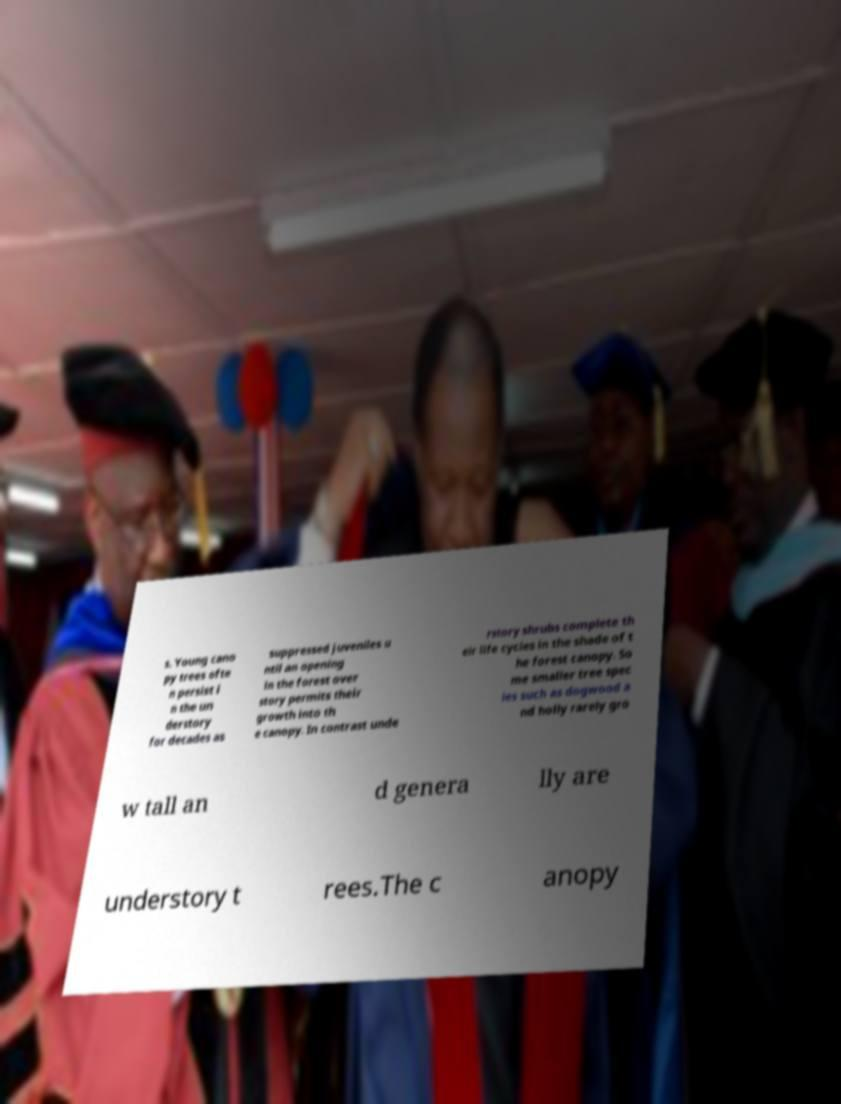Please identify and transcribe the text found in this image. s. Young cano py trees ofte n persist i n the un derstory for decades as suppressed juveniles u ntil an opening in the forest over story permits their growth into th e canopy. In contrast unde rstory shrubs complete th eir life cycles in the shade of t he forest canopy. So me smaller tree spec ies such as dogwood a nd holly rarely gro w tall an d genera lly are understory t rees.The c anopy 